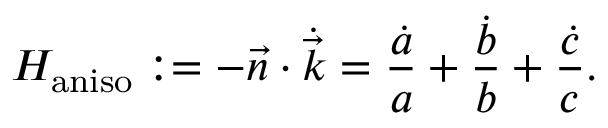Convert formula to latex. <formula><loc_0><loc_0><loc_500><loc_500>H _ { a n i s o } \colon = - \vec { n } \cdot \dot { \vec { k } } = \frac { \dot { a } } { a } + \frac { \dot { b } } { b } + \frac { \dot { c } } { c } .</formula> 